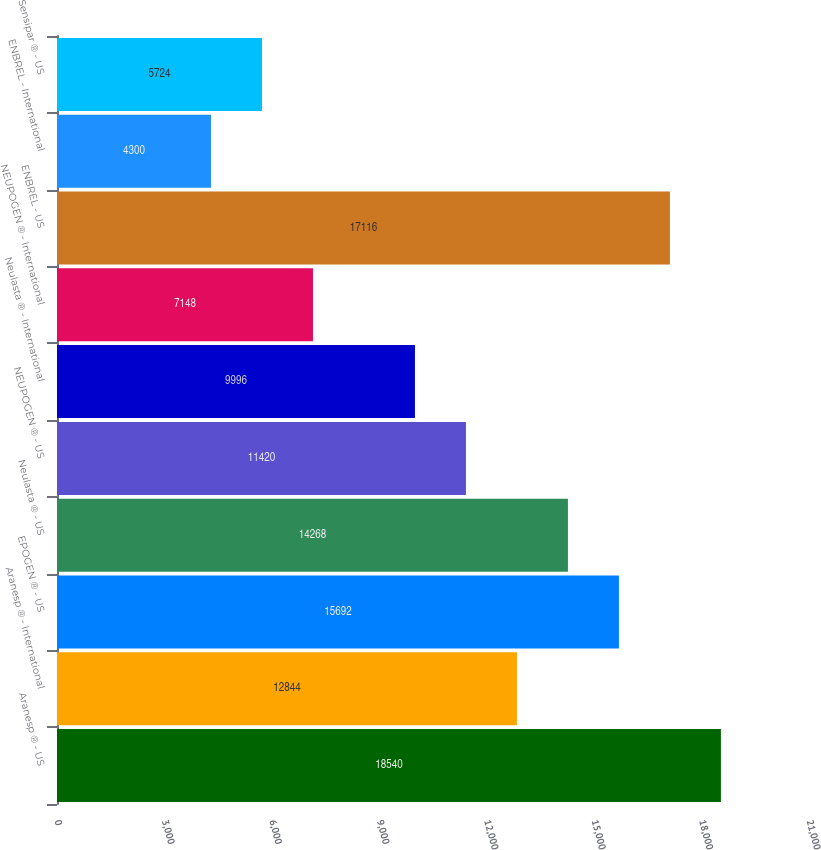<chart> <loc_0><loc_0><loc_500><loc_500><bar_chart><fcel>Aranesp ® - US<fcel>Aranesp ® - International<fcel>EPOGEN ® - US<fcel>Neulasta ® - US<fcel>NEUPOGEN ® - US<fcel>Neulasta ® - International<fcel>NEUPOGEN ® - International<fcel>ENBREL - US<fcel>ENBREL - International<fcel>Sensipar ® - US<nl><fcel>18540<fcel>12844<fcel>15692<fcel>14268<fcel>11420<fcel>9996<fcel>7148<fcel>17116<fcel>4300<fcel>5724<nl></chart> 